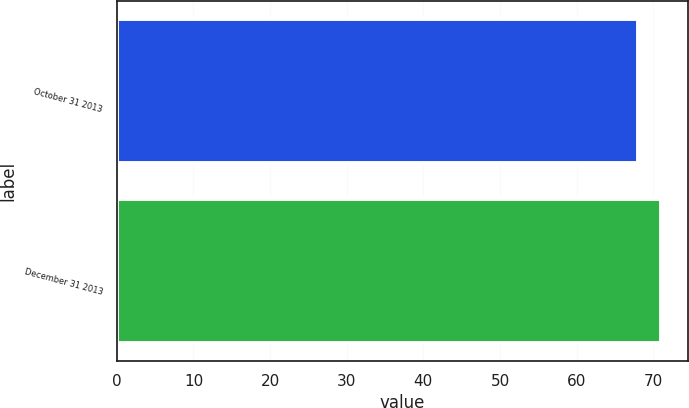Convert chart to OTSL. <chart><loc_0><loc_0><loc_500><loc_500><bar_chart><fcel>October 31 2013<fcel>December 31 2013<nl><fcel>68<fcel>71<nl></chart> 